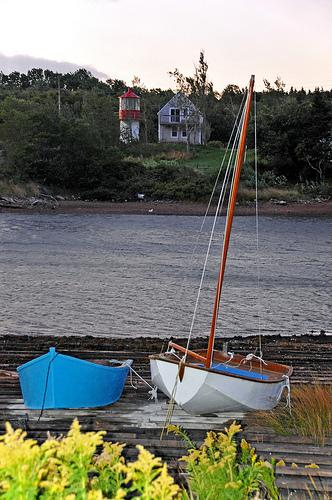Question: what are the boat and canoe docked next to?
Choices:
A. The shore.
B. The dock.
C. Body of water.
D. The beach.
Answer with the letter. Answer: C Question: when is this scene taking place?
Choices:
A. Nighttime.
B. Evening.
C. Morning.
D. Daytime.
Answer with the letter. Answer: D Question: where are the canoe and boat sitting?
Choices:
A. The water.
B. Wooden dock.
C. The shore.
D. The beach.
Answer with the letter. Answer: B 